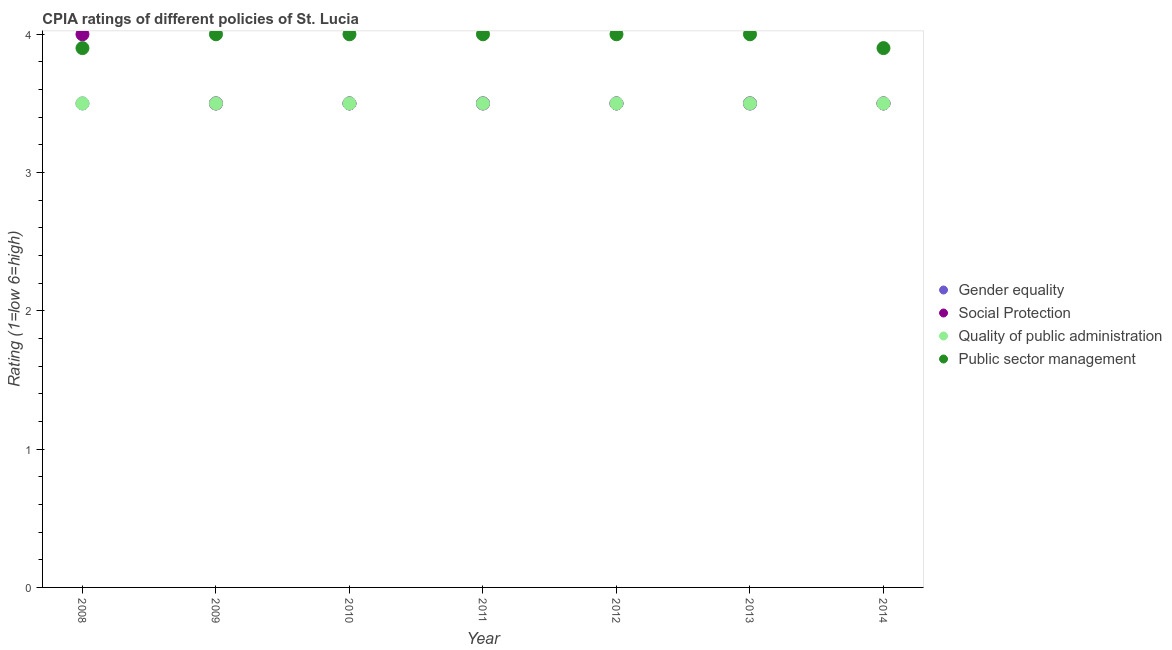Is the number of dotlines equal to the number of legend labels?
Provide a short and direct response. Yes. What is the cpia rating of quality of public administration in 2008?
Provide a short and direct response. 3.5. Across all years, what is the maximum cpia rating of public sector management?
Keep it short and to the point. 4. Across all years, what is the minimum cpia rating of public sector management?
Keep it short and to the point. 3.9. In which year was the cpia rating of gender equality minimum?
Provide a short and direct response. 2008. What is the total cpia rating of gender equality in the graph?
Offer a very short reply. 24.5. What is the average cpia rating of public sector management per year?
Your answer should be compact. 3.97. What is the difference between the highest and the lowest cpia rating of gender equality?
Ensure brevity in your answer.  0. Is it the case that in every year, the sum of the cpia rating of gender equality and cpia rating of quality of public administration is greater than the sum of cpia rating of social protection and cpia rating of public sector management?
Offer a very short reply. No. Does the cpia rating of social protection monotonically increase over the years?
Offer a terse response. No. Is the cpia rating of quality of public administration strictly greater than the cpia rating of social protection over the years?
Make the answer very short. No. Is the cpia rating of quality of public administration strictly less than the cpia rating of gender equality over the years?
Offer a very short reply. No. How many years are there in the graph?
Ensure brevity in your answer.  7. What is the difference between two consecutive major ticks on the Y-axis?
Your answer should be compact. 1. Where does the legend appear in the graph?
Your response must be concise. Center right. How many legend labels are there?
Your response must be concise. 4. What is the title of the graph?
Keep it short and to the point. CPIA ratings of different policies of St. Lucia. Does "Social Awareness" appear as one of the legend labels in the graph?
Your answer should be very brief. No. What is the label or title of the Y-axis?
Offer a very short reply. Rating (1=low 6=high). What is the Rating (1=low 6=high) in Social Protection in 2008?
Your answer should be compact. 4. What is the Rating (1=low 6=high) of Public sector management in 2008?
Give a very brief answer. 3.9. What is the Rating (1=low 6=high) in Social Protection in 2009?
Your answer should be compact. 3.5. What is the Rating (1=low 6=high) of Social Protection in 2010?
Offer a very short reply. 3.5. What is the Rating (1=low 6=high) in Public sector management in 2010?
Your answer should be very brief. 4. What is the Rating (1=low 6=high) in Gender equality in 2011?
Your response must be concise. 3.5. What is the Rating (1=low 6=high) in Public sector management in 2011?
Your answer should be compact. 4. What is the Rating (1=low 6=high) in Gender equality in 2012?
Offer a terse response. 3.5. What is the Rating (1=low 6=high) of Social Protection in 2012?
Your answer should be compact. 3.5. What is the Rating (1=low 6=high) of Public sector management in 2012?
Make the answer very short. 4. What is the Rating (1=low 6=high) in Gender equality in 2013?
Offer a very short reply. 3.5. What is the Rating (1=low 6=high) of Social Protection in 2013?
Offer a terse response. 3.5. What is the Rating (1=low 6=high) of Quality of public administration in 2013?
Make the answer very short. 3.5. What is the Rating (1=low 6=high) in Public sector management in 2013?
Provide a succinct answer. 4. What is the Rating (1=low 6=high) of Gender equality in 2014?
Offer a very short reply. 3.5. Across all years, what is the maximum Rating (1=low 6=high) of Public sector management?
Offer a very short reply. 4. Across all years, what is the minimum Rating (1=low 6=high) of Social Protection?
Your answer should be very brief. 3.5. Across all years, what is the minimum Rating (1=low 6=high) of Quality of public administration?
Provide a succinct answer. 3.5. Across all years, what is the minimum Rating (1=low 6=high) in Public sector management?
Give a very brief answer. 3.9. What is the total Rating (1=low 6=high) in Social Protection in the graph?
Make the answer very short. 25. What is the total Rating (1=low 6=high) in Public sector management in the graph?
Ensure brevity in your answer.  27.8. What is the difference between the Rating (1=low 6=high) in Quality of public administration in 2008 and that in 2009?
Your response must be concise. 0. What is the difference between the Rating (1=low 6=high) of Public sector management in 2008 and that in 2010?
Your response must be concise. -0.1. What is the difference between the Rating (1=low 6=high) of Gender equality in 2008 and that in 2011?
Provide a succinct answer. 0. What is the difference between the Rating (1=low 6=high) of Quality of public administration in 2008 and that in 2011?
Keep it short and to the point. 0. What is the difference between the Rating (1=low 6=high) of Social Protection in 2008 and that in 2012?
Your answer should be compact. 0.5. What is the difference between the Rating (1=low 6=high) in Gender equality in 2008 and that in 2013?
Provide a succinct answer. 0. What is the difference between the Rating (1=low 6=high) of Social Protection in 2008 and that in 2014?
Offer a very short reply. 0.5. What is the difference between the Rating (1=low 6=high) of Quality of public administration in 2008 and that in 2014?
Offer a terse response. 0. What is the difference between the Rating (1=low 6=high) of Social Protection in 2009 and that in 2010?
Keep it short and to the point. 0. What is the difference between the Rating (1=low 6=high) in Quality of public administration in 2009 and that in 2010?
Provide a succinct answer. 0. What is the difference between the Rating (1=low 6=high) in Public sector management in 2009 and that in 2010?
Provide a succinct answer. 0. What is the difference between the Rating (1=low 6=high) in Social Protection in 2009 and that in 2012?
Offer a terse response. 0. What is the difference between the Rating (1=low 6=high) of Quality of public administration in 2009 and that in 2012?
Your answer should be very brief. 0. What is the difference between the Rating (1=low 6=high) in Gender equality in 2009 and that in 2013?
Make the answer very short. 0. What is the difference between the Rating (1=low 6=high) of Social Protection in 2009 and that in 2013?
Your answer should be compact. 0. What is the difference between the Rating (1=low 6=high) in Quality of public administration in 2009 and that in 2013?
Offer a very short reply. 0. What is the difference between the Rating (1=low 6=high) in Public sector management in 2009 and that in 2013?
Offer a very short reply. 0. What is the difference between the Rating (1=low 6=high) in Quality of public administration in 2009 and that in 2014?
Your answer should be very brief. 0. What is the difference between the Rating (1=low 6=high) of Public sector management in 2009 and that in 2014?
Provide a short and direct response. 0.1. What is the difference between the Rating (1=low 6=high) in Gender equality in 2010 and that in 2011?
Your answer should be compact. 0. What is the difference between the Rating (1=low 6=high) in Social Protection in 2010 and that in 2011?
Your answer should be very brief. 0. What is the difference between the Rating (1=low 6=high) of Public sector management in 2010 and that in 2011?
Your answer should be very brief. 0. What is the difference between the Rating (1=low 6=high) of Social Protection in 2010 and that in 2013?
Your response must be concise. 0. What is the difference between the Rating (1=low 6=high) in Quality of public administration in 2010 and that in 2013?
Give a very brief answer. 0. What is the difference between the Rating (1=low 6=high) of Quality of public administration in 2010 and that in 2014?
Ensure brevity in your answer.  0. What is the difference between the Rating (1=low 6=high) of Public sector management in 2010 and that in 2014?
Keep it short and to the point. 0.1. What is the difference between the Rating (1=low 6=high) of Social Protection in 2011 and that in 2012?
Offer a very short reply. 0. What is the difference between the Rating (1=low 6=high) of Public sector management in 2011 and that in 2012?
Offer a terse response. 0. What is the difference between the Rating (1=low 6=high) in Social Protection in 2011 and that in 2014?
Provide a short and direct response. 0. What is the difference between the Rating (1=low 6=high) of Quality of public administration in 2011 and that in 2014?
Provide a succinct answer. 0. What is the difference between the Rating (1=low 6=high) in Public sector management in 2011 and that in 2014?
Ensure brevity in your answer.  0.1. What is the difference between the Rating (1=low 6=high) in Social Protection in 2012 and that in 2013?
Make the answer very short. 0. What is the difference between the Rating (1=low 6=high) in Social Protection in 2013 and that in 2014?
Offer a very short reply. 0. What is the difference between the Rating (1=low 6=high) in Social Protection in 2008 and the Rating (1=low 6=high) in Quality of public administration in 2009?
Provide a succinct answer. 0.5. What is the difference between the Rating (1=low 6=high) in Quality of public administration in 2008 and the Rating (1=low 6=high) in Public sector management in 2009?
Your answer should be compact. -0.5. What is the difference between the Rating (1=low 6=high) in Gender equality in 2008 and the Rating (1=low 6=high) in Social Protection in 2010?
Offer a very short reply. 0. What is the difference between the Rating (1=low 6=high) in Gender equality in 2008 and the Rating (1=low 6=high) in Quality of public administration in 2010?
Provide a succinct answer. 0. What is the difference between the Rating (1=low 6=high) in Gender equality in 2008 and the Rating (1=low 6=high) in Public sector management in 2010?
Offer a terse response. -0.5. What is the difference between the Rating (1=low 6=high) in Gender equality in 2008 and the Rating (1=low 6=high) in Social Protection in 2011?
Your response must be concise. 0. What is the difference between the Rating (1=low 6=high) in Gender equality in 2008 and the Rating (1=low 6=high) in Quality of public administration in 2011?
Ensure brevity in your answer.  0. What is the difference between the Rating (1=low 6=high) in Social Protection in 2008 and the Rating (1=low 6=high) in Quality of public administration in 2011?
Keep it short and to the point. 0.5. What is the difference between the Rating (1=low 6=high) in Social Protection in 2008 and the Rating (1=low 6=high) in Public sector management in 2011?
Provide a succinct answer. 0. What is the difference between the Rating (1=low 6=high) in Gender equality in 2008 and the Rating (1=low 6=high) in Quality of public administration in 2012?
Your answer should be compact. 0. What is the difference between the Rating (1=low 6=high) in Gender equality in 2008 and the Rating (1=low 6=high) in Public sector management in 2012?
Provide a short and direct response. -0.5. What is the difference between the Rating (1=low 6=high) in Social Protection in 2008 and the Rating (1=low 6=high) in Public sector management in 2012?
Keep it short and to the point. 0. What is the difference between the Rating (1=low 6=high) of Quality of public administration in 2008 and the Rating (1=low 6=high) of Public sector management in 2012?
Keep it short and to the point. -0.5. What is the difference between the Rating (1=low 6=high) in Gender equality in 2008 and the Rating (1=low 6=high) in Public sector management in 2013?
Make the answer very short. -0.5. What is the difference between the Rating (1=low 6=high) of Quality of public administration in 2008 and the Rating (1=low 6=high) of Public sector management in 2013?
Provide a short and direct response. -0.5. What is the difference between the Rating (1=low 6=high) in Gender equality in 2008 and the Rating (1=low 6=high) in Social Protection in 2014?
Your answer should be very brief. 0. What is the difference between the Rating (1=low 6=high) in Gender equality in 2008 and the Rating (1=low 6=high) in Quality of public administration in 2014?
Your answer should be compact. 0. What is the difference between the Rating (1=low 6=high) of Gender equality in 2008 and the Rating (1=low 6=high) of Public sector management in 2014?
Provide a short and direct response. -0.4. What is the difference between the Rating (1=low 6=high) in Social Protection in 2008 and the Rating (1=low 6=high) in Public sector management in 2014?
Make the answer very short. 0.1. What is the difference between the Rating (1=low 6=high) of Gender equality in 2009 and the Rating (1=low 6=high) of Quality of public administration in 2010?
Offer a very short reply. 0. What is the difference between the Rating (1=low 6=high) in Social Protection in 2009 and the Rating (1=low 6=high) in Public sector management in 2010?
Offer a terse response. -0.5. What is the difference between the Rating (1=low 6=high) of Quality of public administration in 2009 and the Rating (1=low 6=high) of Public sector management in 2010?
Provide a short and direct response. -0.5. What is the difference between the Rating (1=low 6=high) of Gender equality in 2009 and the Rating (1=low 6=high) of Quality of public administration in 2011?
Provide a short and direct response. 0. What is the difference between the Rating (1=low 6=high) of Gender equality in 2009 and the Rating (1=low 6=high) of Public sector management in 2011?
Offer a very short reply. -0.5. What is the difference between the Rating (1=low 6=high) of Social Protection in 2009 and the Rating (1=low 6=high) of Public sector management in 2011?
Offer a terse response. -0.5. What is the difference between the Rating (1=low 6=high) of Quality of public administration in 2009 and the Rating (1=low 6=high) of Public sector management in 2011?
Your response must be concise. -0.5. What is the difference between the Rating (1=low 6=high) of Gender equality in 2009 and the Rating (1=low 6=high) of Social Protection in 2012?
Ensure brevity in your answer.  0. What is the difference between the Rating (1=low 6=high) in Gender equality in 2009 and the Rating (1=low 6=high) in Quality of public administration in 2012?
Give a very brief answer. 0. What is the difference between the Rating (1=low 6=high) in Gender equality in 2009 and the Rating (1=low 6=high) in Public sector management in 2012?
Offer a very short reply. -0.5. What is the difference between the Rating (1=low 6=high) in Social Protection in 2009 and the Rating (1=low 6=high) in Quality of public administration in 2012?
Provide a succinct answer. 0. What is the difference between the Rating (1=low 6=high) in Social Protection in 2009 and the Rating (1=low 6=high) in Public sector management in 2012?
Your answer should be compact. -0.5. What is the difference between the Rating (1=low 6=high) of Quality of public administration in 2009 and the Rating (1=low 6=high) of Public sector management in 2012?
Your answer should be very brief. -0.5. What is the difference between the Rating (1=low 6=high) of Gender equality in 2009 and the Rating (1=low 6=high) of Social Protection in 2013?
Keep it short and to the point. 0. What is the difference between the Rating (1=low 6=high) in Gender equality in 2009 and the Rating (1=low 6=high) in Quality of public administration in 2013?
Provide a short and direct response. 0. What is the difference between the Rating (1=low 6=high) in Social Protection in 2009 and the Rating (1=low 6=high) in Quality of public administration in 2013?
Make the answer very short. 0. What is the difference between the Rating (1=low 6=high) in Social Protection in 2009 and the Rating (1=low 6=high) in Public sector management in 2013?
Ensure brevity in your answer.  -0.5. What is the difference between the Rating (1=low 6=high) of Quality of public administration in 2009 and the Rating (1=low 6=high) of Public sector management in 2013?
Your response must be concise. -0.5. What is the difference between the Rating (1=low 6=high) in Gender equality in 2009 and the Rating (1=low 6=high) in Social Protection in 2014?
Offer a very short reply. 0. What is the difference between the Rating (1=low 6=high) of Social Protection in 2009 and the Rating (1=low 6=high) of Quality of public administration in 2014?
Offer a very short reply. 0. What is the difference between the Rating (1=low 6=high) of Quality of public administration in 2009 and the Rating (1=low 6=high) of Public sector management in 2014?
Ensure brevity in your answer.  -0.4. What is the difference between the Rating (1=low 6=high) in Gender equality in 2010 and the Rating (1=low 6=high) in Social Protection in 2011?
Keep it short and to the point. 0. What is the difference between the Rating (1=low 6=high) of Gender equality in 2010 and the Rating (1=low 6=high) of Public sector management in 2011?
Ensure brevity in your answer.  -0.5. What is the difference between the Rating (1=low 6=high) of Social Protection in 2010 and the Rating (1=low 6=high) of Public sector management in 2011?
Offer a terse response. -0.5. What is the difference between the Rating (1=low 6=high) of Quality of public administration in 2010 and the Rating (1=low 6=high) of Public sector management in 2011?
Your answer should be compact. -0.5. What is the difference between the Rating (1=low 6=high) in Gender equality in 2010 and the Rating (1=low 6=high) in Quality of public administration in 2012?
Provide a short and direct response. 0. What is the difference between the Rating (1=low 6=high) in Gender equality in 2010 and the Rating (1=low 6=high) in Public sector management in 2012?
Your answer should be compact. -0.5. What is the difference between the Rating (1=low 6=high) of Quality of public administration in 2010 and the Rating (1=low 6=high) of Public sector management in 2012?
Provide a short and direct response. -0.5. What is the difference between the Rating (1=low 6=high) of Gender equality in 2010 and the Rating (1=low 6=high) of Quality of public administration in 2013?
Your answer should be very brief. 0. What is the difference between the Rating (1=low 6=high) in Gender equality in 2010 and the Rating (1=low 6=high) in Public sector management in 2013?
Ensure brevity in your answer.  -0.5. What is the difference between the Rating (1=low 6=high) in Social Protection in 2010 and the Rating (1=low 6=high) in Quality of public administration in 2013?
Provide a short and direct response. 0. What is the difference between the Rating (1=low 6=high) in Gender equality in 2010 and the Rating (1=low 6=high) in Social Protection in 2014?
Keep it short and to the point. 0. What is the difference between the Rating (1=low 6=high) in Social Protection in 2010 and the Rating (1=low 6=high) in Public sector management in 2014?
Provide a succinct answer. -0.4. What is the difference between the Rating (1=low 6=high) of Gender equality in 2011 and the Rating (1=low 6=high) of Social Protection in 2012?
Your answer should be very brief. 0. What is the difference between the Rating (1=low 6=high) in Social Protection in 2011 and the Rating (1=low 6=high) in Quality of public administration in 2012?
Provide a succinct answer. 0. What is the difference between the Rating (1=low 6=high) in Gender equality in 2011 and the Rating (1=low 6=high) in Quality of public administration in 2013?
Your response must be concise. 0. What is the difference between the Rating (1=low 6=high) of Social Protection in 2011 and the Rating (1=low 6=high) of Quality of public administration in 2013?
Offer a terse response. 0. What is the difference between the Rating (1=low 6=high) of Gender equality in 2011 and the Rating (1=low 6=high) of Social Protection in 2014?
Keep it short and to the point. 0. What is the difference between the Rating (1=low 6=high) of Gender equality in 2011 and the Rating (1=low 6=high) of Quality of public administration in 2014?
Provide a succinct answer. 0. What is the difference between the Rating (1=low 6=high) of Gender equality in 2011 and the Rating (1=low 6=high) of Public sector management in 2014?
Your response must be concise. -0.4. What is the difference between the Rating (1=low 6=high) in Social Protection in 2011 and the Rating (1=low 6=high) in Quality of public administration in 2014?
Offer a very short reply. 0. What is the difference between the Rating (1=low 6=high) in Social Protection in 2011 and the Rating (1=low 6=high) in Public sector management in 2014?
Give a very brief answer. -0.4. What is the difference between the Rating (1=low 6=high) in Quality of public administration in 2011 and the Rating (1=low 6=high) in Public sector management in 2014?
Ensure brevity in your answer.  -0.4. What is the difference between the Rating (1=low 6=high) in Gender equality in 2012 and the Rating (1=low 6=high) in Quality of public administration in 2013?
Your response must be concise. 0. What is the difference between the Rating (1=low 6=high) of Quality of public administration in 2012 and the Rating (1=low 6=high) of Public sector management in 2013?
Keep it short and to the point. -0.5. What is the difference between the Rating (1=low 6=high) in Gender equality in 2012 and the Rating (1=low 6=high) in Social Protection in 2014?
Offer a very short reply. 0. What is the difference between the Rating (1=low 6=high) in Social Protection in 2012 and the Rating (1=low 6=high) in Quality of public administration in 2014?
Provide a short and direct response. 0. What is the difference between the Rating (1=low 6=high) of Gender equality in 2013 and the Rating (1=low 6=high) of Public sector management in 2014?
Your answer should be compact. -0.4. What is the difference between the Rating (1=low 6=high) of Social Protection in 2013 and the Rating (1=low 6=high) of Quality of public administration in 2014?
Your answer should be compact. 0. What is the average Rating (1=low 6=high) of Gender equality per year?
Keep it short and to the point. 3.5. What is the average Rating (1=low 6=high) of Social Protection per year?
Offer a terse response. 3.57. What is the average Rating (1=low 6=high) of Quality of public administration per year?
Your response must be concise. 3.5. What is the average Rating (1=low 6=high) in Public sector management per year?
Ensure brevity in your answer.  3.97. In the year 2008, what is the difference between the Rating (1=low 6=high) of Gender equality and Rating (1=low 6=high) of Quality of public administration?
Your answer should be very brief. 0. In the year 2008, what is the difference between the Rating (1=low 6=high) in Gender equality and Rating (1=low 6=high) in Public sector management?
Offer a very short reply. -0.4. In the year 2008, what is the difference between the Rating (1=low 6=high) of Social Protection and Rating (1=low 6=high) of Public sector management?
Provide a succinct answer. 0.1. In the year 2008, what is the difference between the Rating (1=low 6=high) in Quality of public administration and Rating (1=low 6=high) in Public sector management?
Keep it short and to the point. -0.4. In the year 2009, what is the difference between the Rating (1=low 6=high) of Gender equality and Rating (1=low 6=high) of Social Protection?
Make the answer very short. 0. In the year 2009, what is the difference between the Rating (1=low 6=high) of Gender equality and Rating (1=low 6=high) of Quality of public administration?
Offer a terse response. 0. In the year 2009, what is the difference between the Rating (1=low 6=high) in Quality of public administration and Rating (1=low 6=high) in Public sector management?
Your answer should be very brief. -0.5. In the year 2010, what is the difference between the Rating (1=low 6=high) in Gender equality and Rating (1=low 6=high) in Quality of public administration?
Offer a terse response. 0. In the year 2010, what is the difference between the Rating (1=low 6=high) in Quality of public administration and Rating (1=low 6=high) in Public sector management?
Provide a succinct answer. -0.5. In the year 2011, what is the difference between the Rating (1=low 6=high) in Gender equality and Rating (1=low 6=high) in Quality of public administration?
Give a very brief answer. 0. In the year 2011, what is the difference between the Rating (1=low 6=high) of Social Protection and Rating (1=low 6=high) of Quality of public administration?
Make the answer very short. 0. In the year 2011, what is the difference between the Rating (1=low 6=high) of Social Protection and Rating (1=low 6=high) of Public sector management?
Your answer should be very brief. -0.5. In the year 2011, what is the difference between the Rating (1=low 6=high) in Quality of public administration and Rating (1=low 6=high) in Public sector management?
Your answer should be very brief. -0.5. In the year 2012, what is the difference between the Rating (1=low 6=high) in Gender equality and Rating (1=low 6=high) in Social Protection?
Your answer should be compact. 0. In the year 2012, what is the difference between the Rating (1=low 6=high) in Social Protection and Rating (1=low 6=high) in Quality of public administration?
Make the answer very short. 0. In the year 2012, what is the difference between the Rating (1=low 6=high) of Quality of public administration and Rating (1=low 6=high) of Public sector management?
Provide a short and direct response. -0.5. In the year 2013, what is the difference between the Rating (1=low 6=high) of Gender equality and Rating (1=low 6=high) of Social Protection?
Provide a succinct answer. 0. In the year 2013, what is the difference between the Rating (1=low 6=high) in Gender equality and Rating (1=low 6=high) in Quality of public administration?
Keep it short and to the point. 0. In the year 2013, what is the difference between the Rating (1=low 6=high) of Gender equality and Rating (1=low 6=high) of Public sector management?
Provide a short and direct response. -0.5. In the year 2013, what is the difference between the Rating (1=low 6=high) of Social Protection and Rating (1=low 6=high) of Quality of public administration?
Give a very brief answer. 0. In the year 2013, what is the difference between the Rating (1=low 6=high) of Social Protection and Rating (1=low 6=high) of Public sector management?
Keep it short and to the point. -0.5. In the year 2013, what is the difference between the Rating (1=low 6=high) of Quality of public administration and Rating (1=low 6=high) of Public sector management?
Provide a succinct answer. -0.5. In the year 2014, what is the difference between the Rating (1=low 6=high) of Gender equality and Rating (1=low 6=high) of Social Protection?
Make the answer very short. 0. In the year 2014, what is the difference between the Rating (1=low 6=high) in Gender equality and Rating (1=low 6=high) in Quality of public administration?
Offer a terse response. 0. In the year 2014, what is the difference between the Rating (1=low 6=high) of Social Protection and Rating (1=low 6=high) of Public sector management?
Your answer should be compact. -0.4. What is the ratio of the Rating (1=low 6=high) of Gender equality in 2008 to that in 2009?
Ensure brevity in your answer.  1. What is the ratio of the Rating (1=low 6=high) of Social Protection in 2008 to that in 2009?
Keep it short and to the point. 1.14. What is the ratio of the Rating (1=low 6=high) of Quality of public administration in 2008 to that in 2009?
Offer a very short reply. 1. What is the ratio of the Rating (1=low 6=high) in Gender equality in 2008 to that in 2010?
Ensure brevity in your answer.  1. What is the ratio of the Rating (1=low 6=high) in Quality of public administration in 2008 to that in 2011?
Make the answer very short. 1. What is the ratio of the Rating (1=low 6=high) in Gender equality in 2008 to that in 2012?
Your answer should be compact. 1. What is the ratio of the Rating (1=low 6=high) of Social Protection in 2008 to that in 2012?
Make the answer very short. 1.14. What is the ratio of the Rating (1=low 6=high) in Public sector management in 2008 to that in 2012?
Provide a succinct answer. 0.97. What is the ratio of the Rating (1=low 6=high) of Social Protection in 2008 to that in 2013?
Your answer should be compact. 1.14. What is the ratio of the Rating (1=low 6=high) in Public sector management in 2008 to that in 2013?
Provide a succinct answer. 0.97. What is the ratio of the Rating (1=low 6=high) in Gender equality in 2008 to that in 2014?
Your answer should be compact. 1. What is the ratio of the Rating (1=low 6=high) of Social Protection in 2008 to that in 2014?
Keep it short and to the point. 1.14. What is the ratio of the Rating (1=low 6=high) of Social Protection in 2009 to that in 2010?
Keep it short and to the point. 1. What is the ratio of the Rating (1=low 6=high) in Quality of public administration in 2009 to that in 2010?
Your answer should be compact. 1. What is the ratio of the Rating (1=low 6=high) of Gender equality in 2009 to that in 2011?
Make the answer very short. 1. What is the ratio of the Rating (1=low 6=high) of Public sector management in 2009 to that in 2011?
Keep it short and to the point. 1. What is the ratio of the Rating (1=low 6=high) in Social Protection in 2009 to that in 2013?
Ensure brevity in your answer.  1. What is the ratio of the Rating (1=low 6=high) in Quality of public administration in 2009 to that in 2013?
Offer a very short reply. 1. What is the ratio of the Rating (1=low 6=high) of Public sector management in 2009 to that in 2014?
Provide a short and direct response. 1.03. What is the ratio of the Rating (1=low 6=high) in Public sector management in 2010 to that in 2011?
Ensure brevity in your answer.  1. What is the ratio of the Rating (1=low 6=high) of Social Protection in 2010 to that in 2012?
Your answer should be very brief. 1. What is the ratio of the Rating (1=low 6=high) in Quality of public administration in 2010 to that in 2012?
Offer a terse response. 1. What is the ratio of the Rating (1=low 6=high) of Gender equality in 2010 to that in 2013?
Offer a terse response. 1. What is the ratio of the Rating (1=low 6=high) of Gender equality in 2010 to that in 2014?
Keep it short and to the point. 1. What is the ratio of the Rating (1=low 6=high) in Quality of public administration in 2010 to that in 2014?
Give a very brief answer. 1. What is the ratio of the Rating (1=low 6=high) in Public sector management in 2010 to that in 2014?
Your response must be concise. 1.03. What is the ratio of the Rating (1=low 6=high) in Gender equality in 2011 to that in 2012?
Provide a short and direct response. 1. What is the ratio of the Rating (1=low 6=high) in Social Protection in 2011 to that in 2012?
Give a very brief answer. 1. What is the ratio of the Rating (1=low 6=high) of Quality of public administration in 2011 to that in 2012?
Ensure brevity in your answer.  1. What is the ratio of the Rating (1=low 6=high) in Public sector management in 2011 to that in 2012?
Give a very brief answer. 1. What is the ratio of the Rating (1=low 6=high) of Social Protection in 2011 to that in 2013?
Keep it short and to the point. 1. What is the ratio of the Rating (1=low 6=high) in Gender equality in 2011 to that in 2014?
Your response must be concise. 1. What is the ratio of the Rating (1=low 6=high) in Social Protection in 2011 to that in 2014?
Your answer should be very brief. 1. What is the ratio of the Rating (1=low 6=high) in Public sector management in 2011 to that in 2014?
Offer a terse response. 1.03. What is the ratio of the Rating (1=low 6=high) in Public sector management in 2012 to that in 2013?
Give a very brief answer. 1. What is the ratio of the Rating (1=low 6=high) in Quality of public administration in 2012 to that in 2014?
Your answer should be very brief. 1. What is the ratio of the Rating (1=low 6=high) of Public sector management in 2012 to that in 2014?
Keep it short and to the point. 1.03. What is the ratio of the Rating (1=low 6=high) of Gender equality in 2013 to that in 2014?
Provide a succinct answer. 1. What is the ratio of the Rating (1=low 6=high) of Social Protection in 2013 to that in 2014?
Provide a succinct answer. 1. What is the ratio of the Rating (1=low 6=high) in Quality of public administration in 2013 to that in 2014?
Offer a terse response. 1. What is the ratio of the Rating (1=low 6=high) of Public sector management in 2013 to that in 2014?
Offer a very short reply. 1.03. What is the difference between the highest and the second highest Rating (1=low 6=high) of Social Protection?
Provide a short and direct response. 0.5. What is the difference between the highest and the second highest Rating (1=low 6=high) of Quality of public administration?
Your answer should be very brief. 0. What is the difference between the highest and the lowest Rating (1=low 6=high) in Public sector management?
Provide a short and direct response. 0.1. 